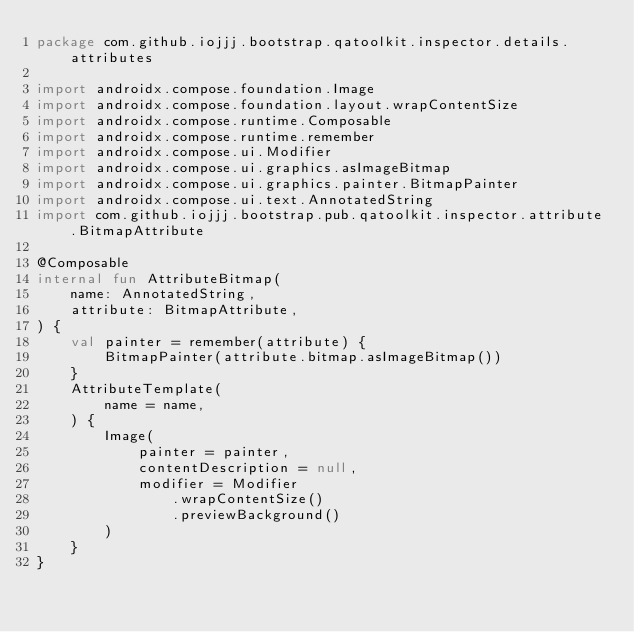<code> <loc_0><loc_0><loc_500><loc_500><_Kotlin_>package com.github.iojjj.bootstrap.qatoolkit.inspector.details.attributes

import androidx.compose.foundation.Image
import androidx.compose.foundation.layout.wrapContentSize
import androidx.compose.runtime.Composable
import androidx.compose.runtime.remember
import androidx.compose.ui.Modifier
import androidx.compose.ui.graphics.asImageBitmap
import androidx.compose.ui.graphics.painter.BitmapPainter
import androidx.compose.ui.text.AnnotatedString
import com.github.iojjj.bootstrap.pub.qatoolkit.inspector.attribute.BitmapAttribute

@Composable
internal fun AttributeBitmap(
    name: AnnotatedString,
    attribute: BitmapAttribute,
) {
    val painter = remember(attribute) {
        BitmapPainter(attribute.bitmap.asImageBitmap())
    }
    AttributeTemplate(
        name = name,
    ) {
        Image(
            painter = painter,
            contentDescription = null,
            modifier = Modifier
                .wrapContentSize()
                .previewBackground()
        )
    }
}</code> 